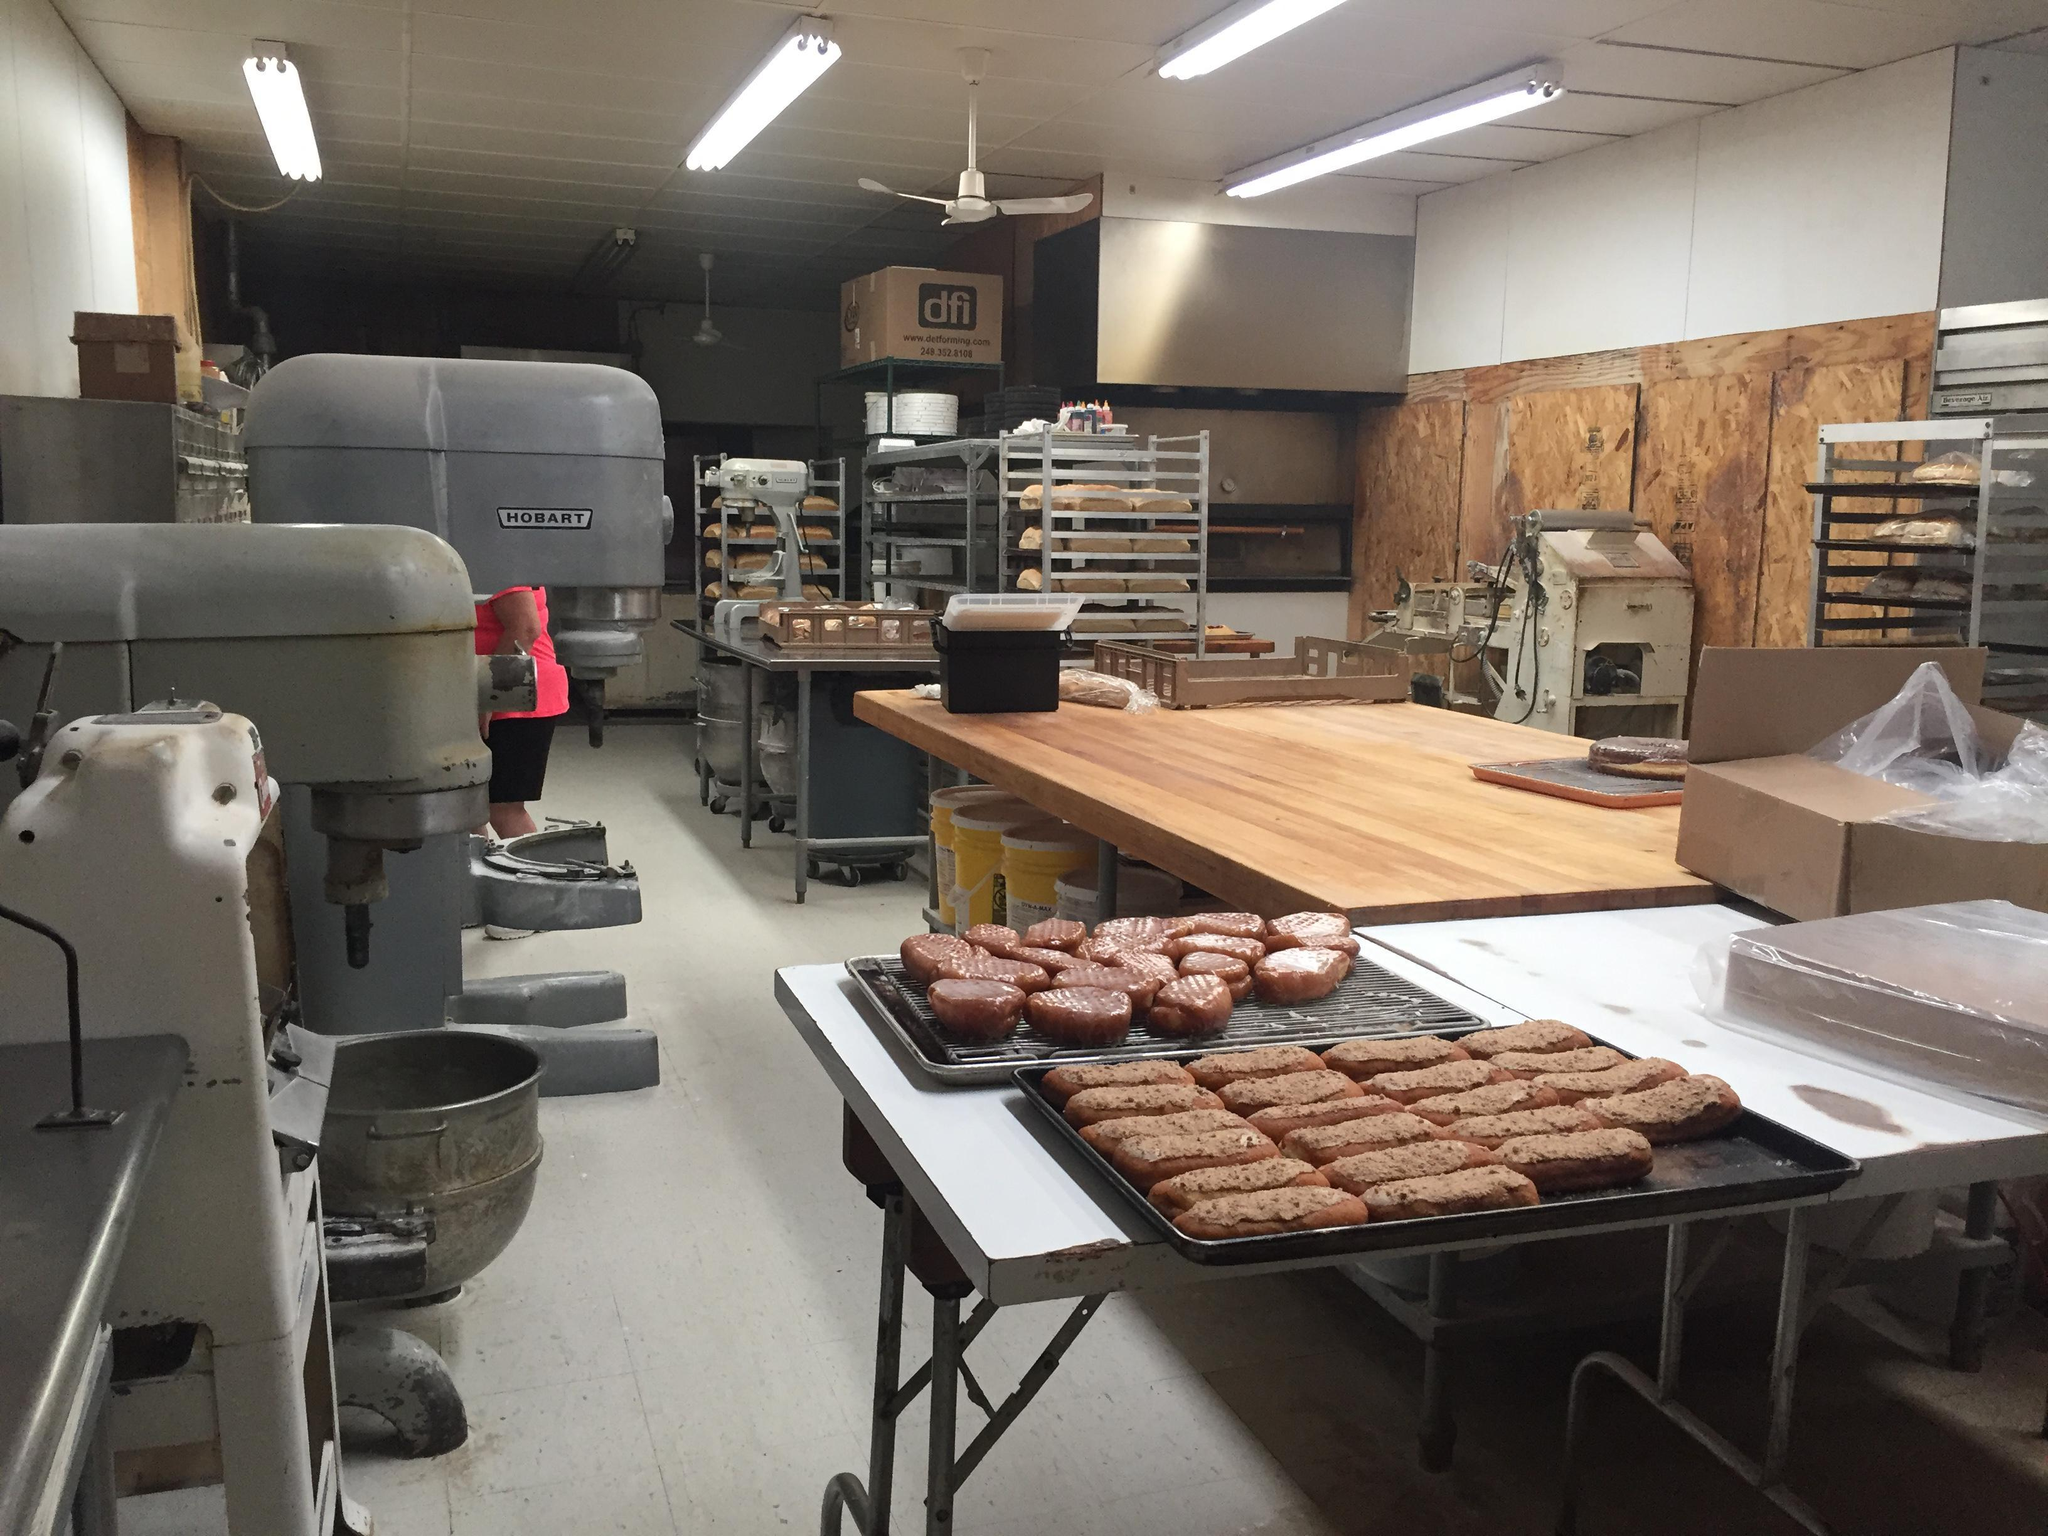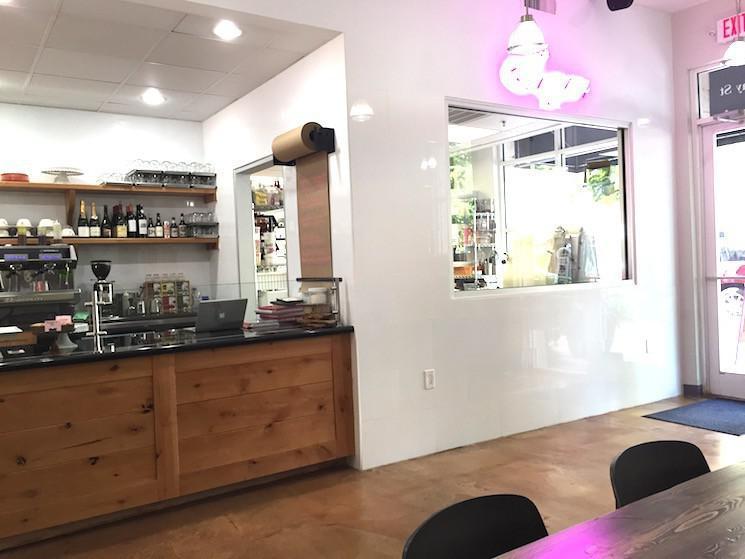The first image is the image on the left, the second image is the image on the right. Considering the images on both sides, is "There is a chalkboard with writing on it." valid? Answer yes or no. No. The first image is the image on the left, the second image is the image on the right. For the images shown, is this caption "The left image includes a baked item displayed on a pedestal." true? Answer yes or no. No. 